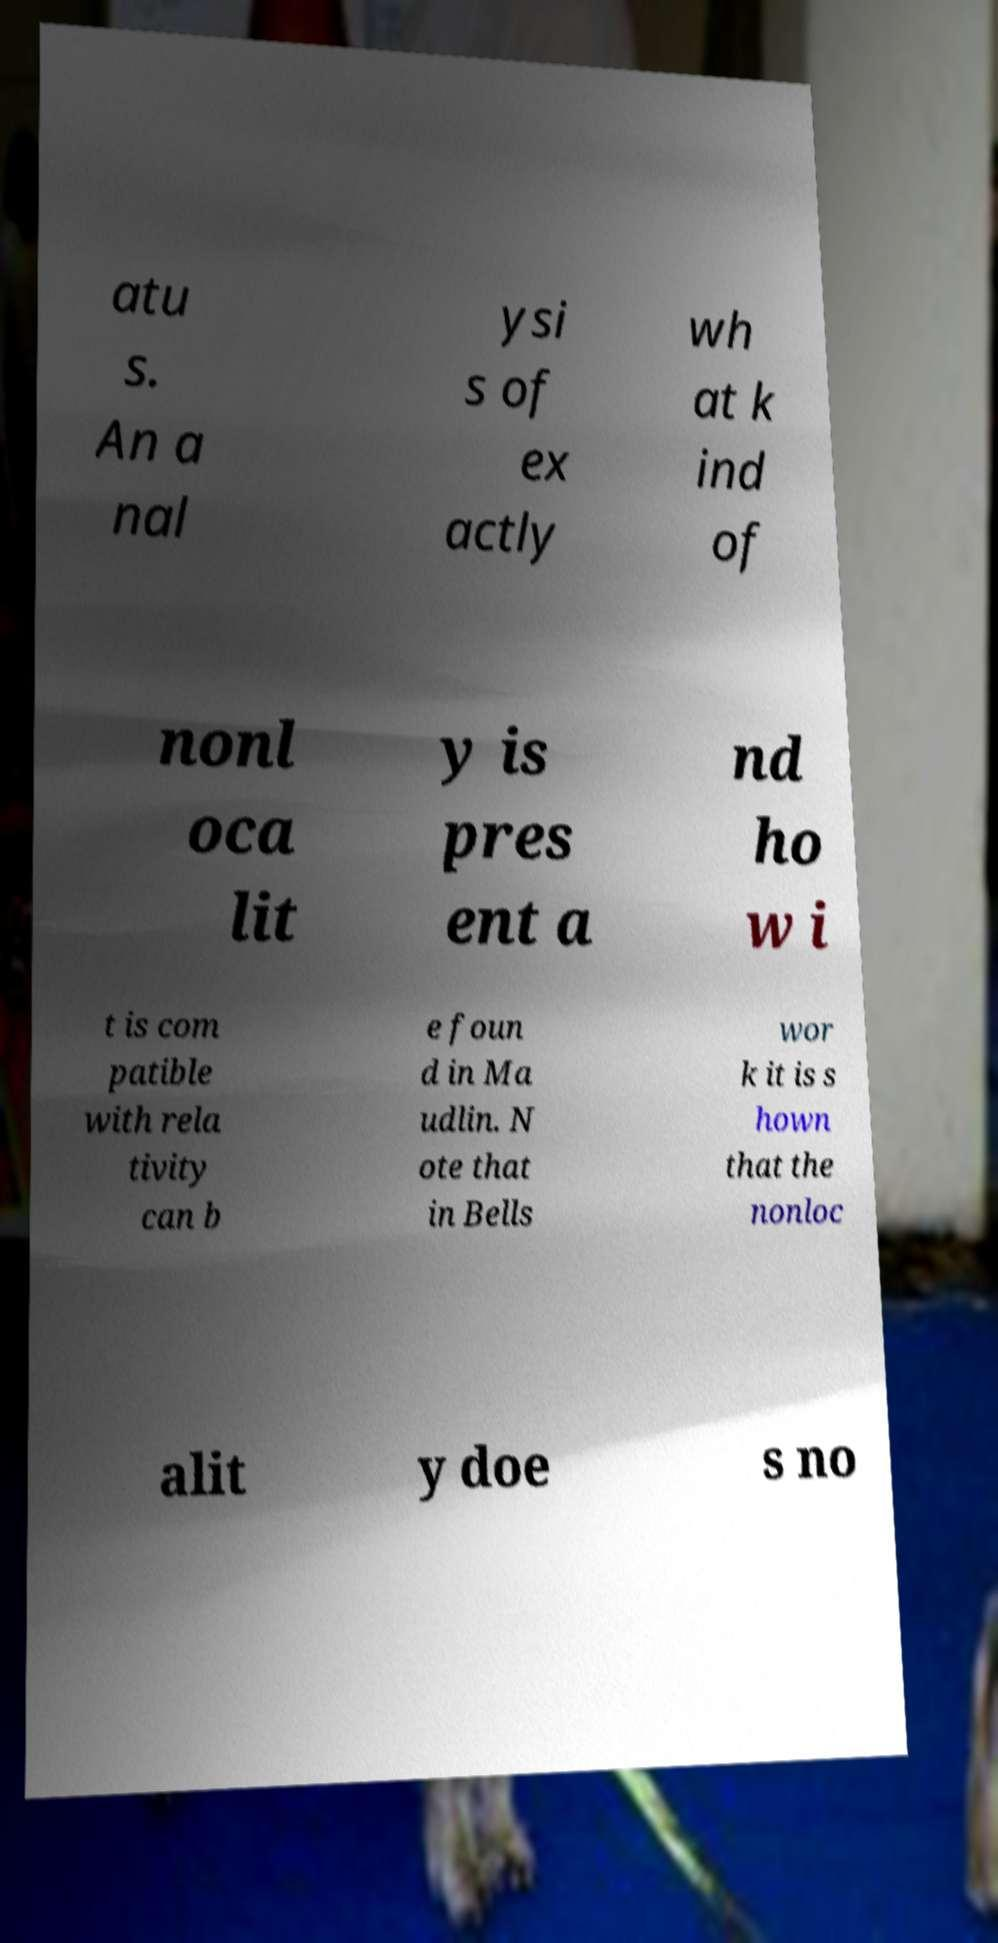Please read and relay the text visible in this image. What does it say? atu s. An a nal ysi s of ex actly wh at k ind of nonl oca lit y is pres ent a nd ho w i t is com patible with rela tivity can b e foun d in Ma udlin. N ote that in Bells wor k it is s hown that the nonloc alit y doe s no 